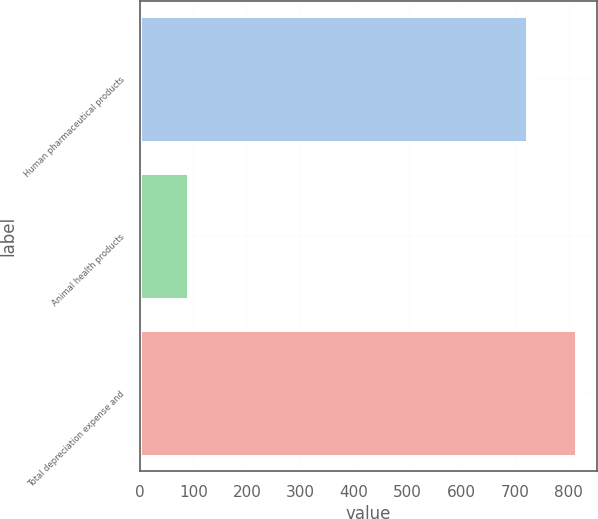<chart> <loc_0><loc_0><loc_500><loc_500><bar_chart><fcel>Human pharmaceutical products<fcel>Animal health products<fcel>Total depreciation expense and<nl><fcel>723.4<fcel>89.9<fcel>813.3<nl></chart> 